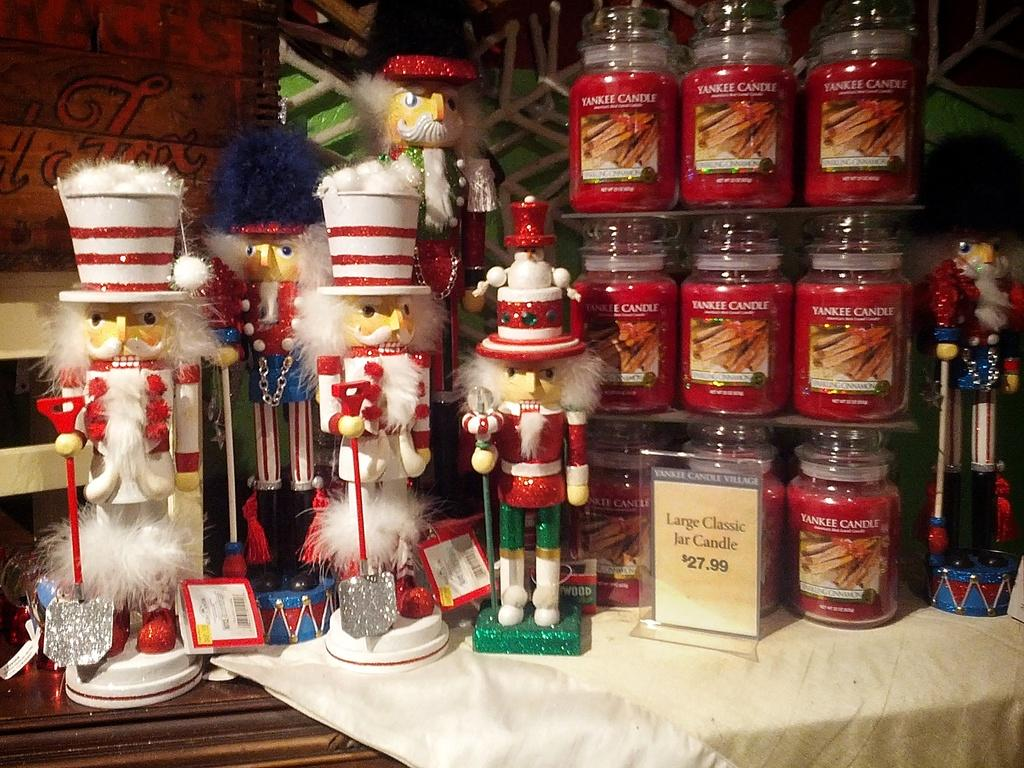<image>
Present a compact description of the photo's key features. Various holiday nutcracker dolls next to a display of Yankee Candles. 